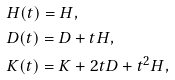Convert formula to latex. <formula><loc_0><loc_0><loc_500><loc_500>& H ( t ) = H , \\ & D ( t ) = D + t H , \\ & K ( t ) = K + 2 t D + t ^ { 2 } H ,</formula> 